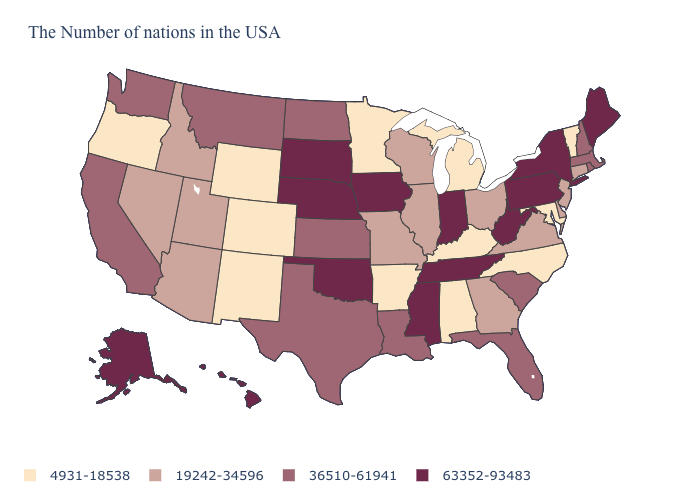What is the value of Wyoming?
Answer briefly. 4931-18538. Does Alaska have the highest value in the West?
Concise answer only. Yes. What is the highest value in the USA?
Short answer required. 63352-93483. Is the legend a continuous bar?
Write a very short answer. No. What is the value of Arkansas?
Keep it brief. 4931-18538. Which states hav the highest value in the West?
Short answer required. Alaska, Hawaii. Does California have a higher value than Utah?
Keep it brief. Yes. Among the states that border Iowa , does Minnesota have the lowest value?
Answer briefly. Yes. What is the value of South Dakota?
Give a very brief answer. 63352-93483. Name the states that have a value in the range 19242-34596?
Write a very short answer. Connecticut, New Jersey, Delaware, Virginia, Ohio, Georgia, Wisconsin, Illinois, Missouri, Utah, Arizona, Idaho, Nevada. What is the value of Maine?
Keep it brief. 63352-93483. Name the states that have a value in the range 36510-61941?
Answer briefly. Massachusetts, Rhode Island, New Hampshire, South Carolina, Florida, Louisiana, Kansas, Texas, North Dakota, Montana, California, Washington. Name the states that have a value in the range 4931-18538?
Write a very short answer. Vermont, Maryland, North Carolina, Michigan, Kentucky, Alabama, Arkansas, Minnesota, Wyoming, Colorado, New Mexico, Oregon. Does Indiana have the highest value in the USA?
Concise answer only. Yes. What is the lowest value in the USA?
Concise answer only. 4931-18538. 